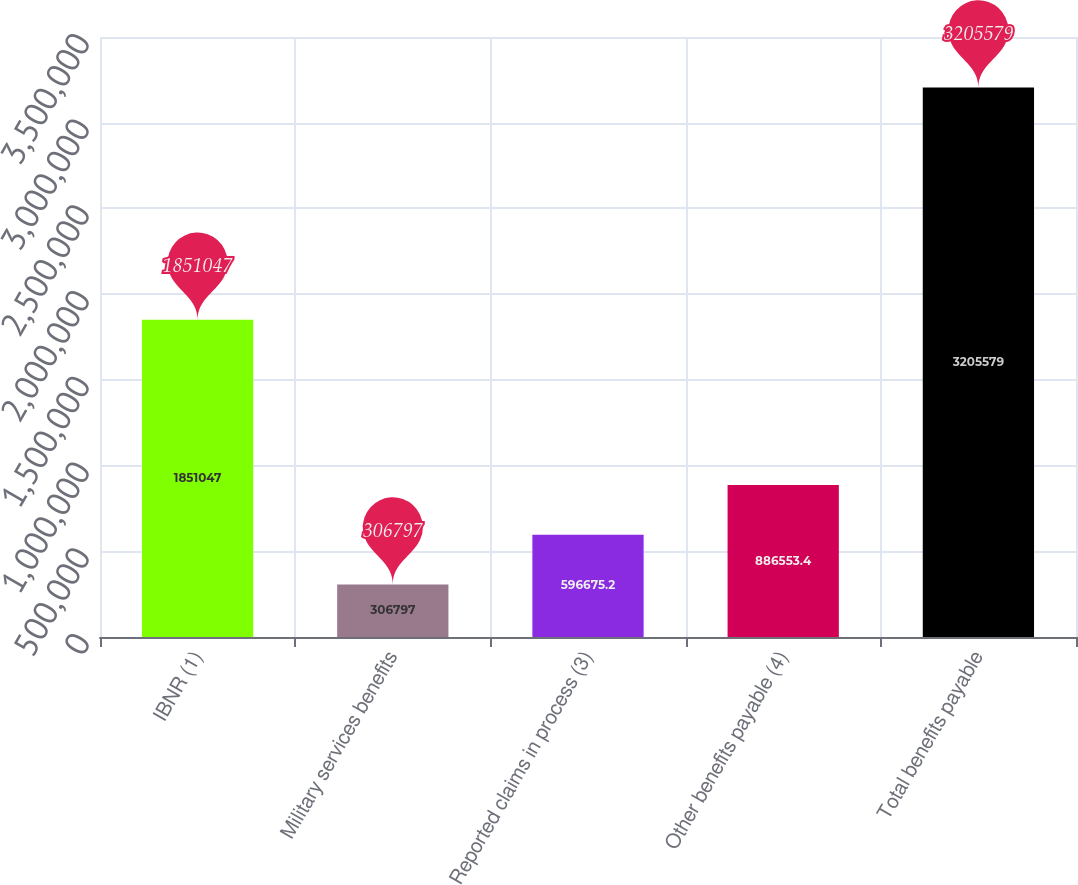<chart> <loc_0><loc_0><loc_500><loc_500><bar_chart><fcel>IBNR (1)<fcel>Military services benefits<fcel>Reported claims in process (3)<fcel>Other benefits payable (4)<fcel>Total benefits payable<nl><fcel>1.85105e+06<fcel>306797<fcel>596675<fcel>886553<fcel>3.20558e+06<nl></chart> 